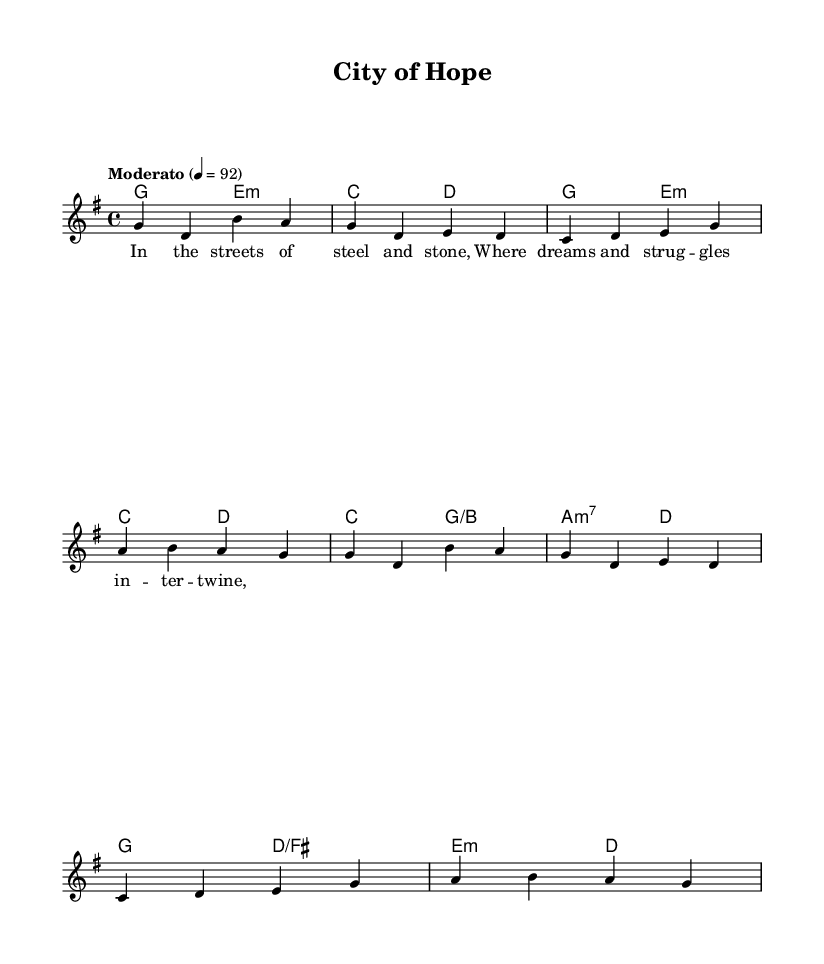What is the key signature of this music? The key signature is G major, which has one sharp (F#). This can be determined by looking at the key signature shown at the beginning of the staff.
Answer: G major What is the time signature of this piece? The time signature is 4/4, indicated at the beginning of the score. This means there are four beats in each measure, and the quarter note gets one beat.
Answer: 4/4 What is the tempo marking for this music? The tempo marking is "Moderato," which suggests a moderate speed, and it is further specified by the metronome marking of 92 beats per minute. This informs the performer about the intended pace while playing the piece.
Answer: Moderato How many measures are in the melody? The melody consists of four measures. You can count the vertical bar lines, which separate each measure, to determine the total number present in the melody line.
Answer: 4 What is the last word of the lyrics? The last word of the lyrics is "twine." This is found at the end of the lyric line, giving a sense of closure to the verse.
Answer: twine What is the harmonic structure at the beginning of the score? The harmonic structure at the beginning is G major and E minor. This is identified by looking at the first chord names indicated above the melody, showing the foundational chords supporting the music in the introduction.
Answer: G major, E minor What type of song is this considered? This song is considered a modern hymn. The lyrics and musical style reflect themes common in hymns, centered on social justice and urban life, which is characteristic of contemporary religious music.
Answer: modern hymn 